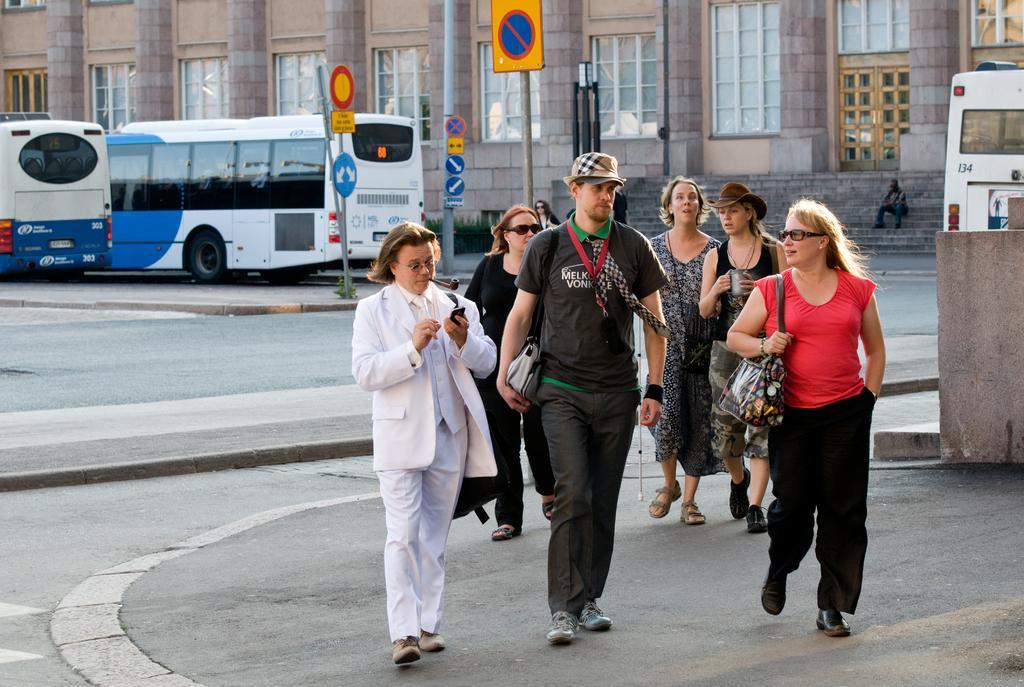How would you summarize this image in a sentence or two? In this picture we can see some people are walking, on the left side there are two buses, we can see poles and boards in the middle, in the background there is a building, the two persons in the front are carrying bags. 